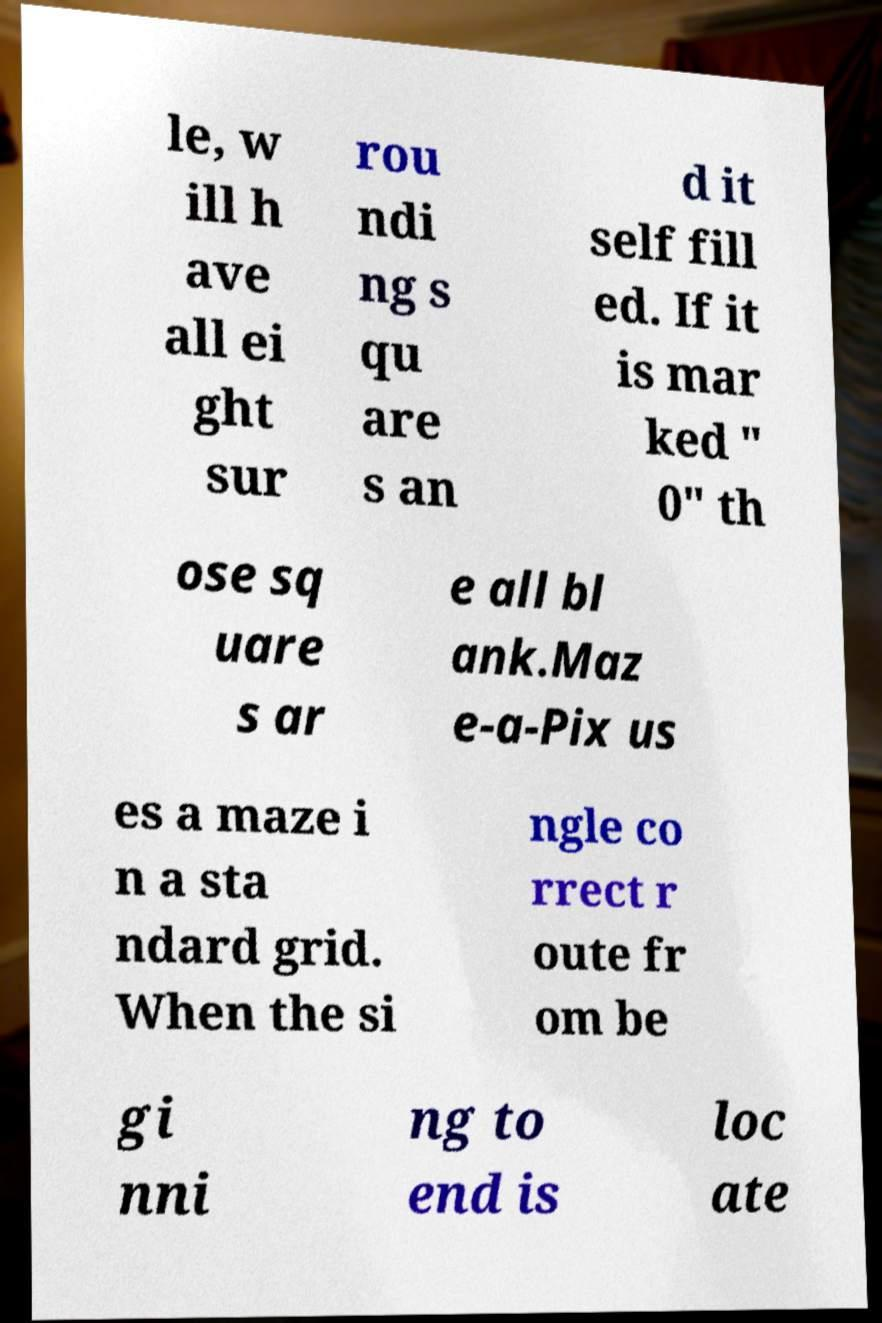Can you accurately transcribe the text from the provided image for me? le, w ill h ave all ei ght sur rou ndi ng s qu are s an d it self fill ed. If it is mar ked " 0" th ose sq uare s ar e all bl ank.Maz e-a-Pix us es a maze i n a sta ndard grid. When the si ngle co rrect r oute fr om be gi nni ng to end is loc ate 